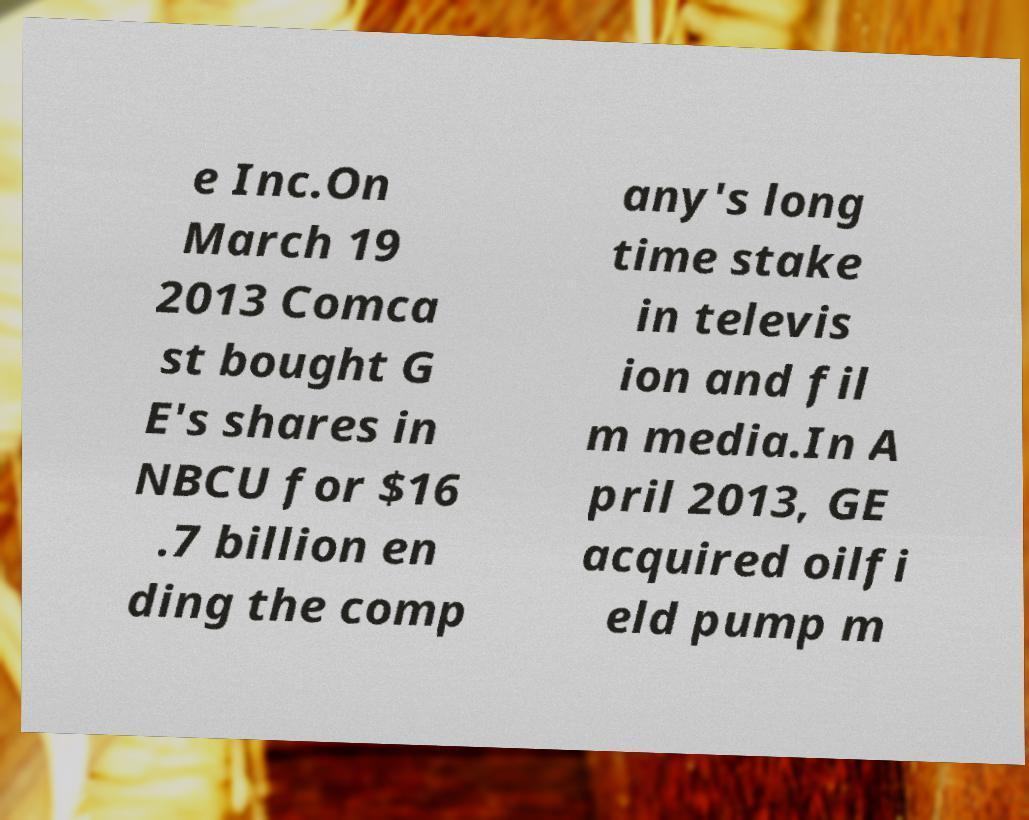Could you extract and type out the text from this image? e Inc.On March 19 2013 Comca st bought G E's shares in NBCU for $16 .7 billion en ding the comp any's long time stake in televis ion and fil m media.In A pril 2013, GE acquired oilfi eld pump m 